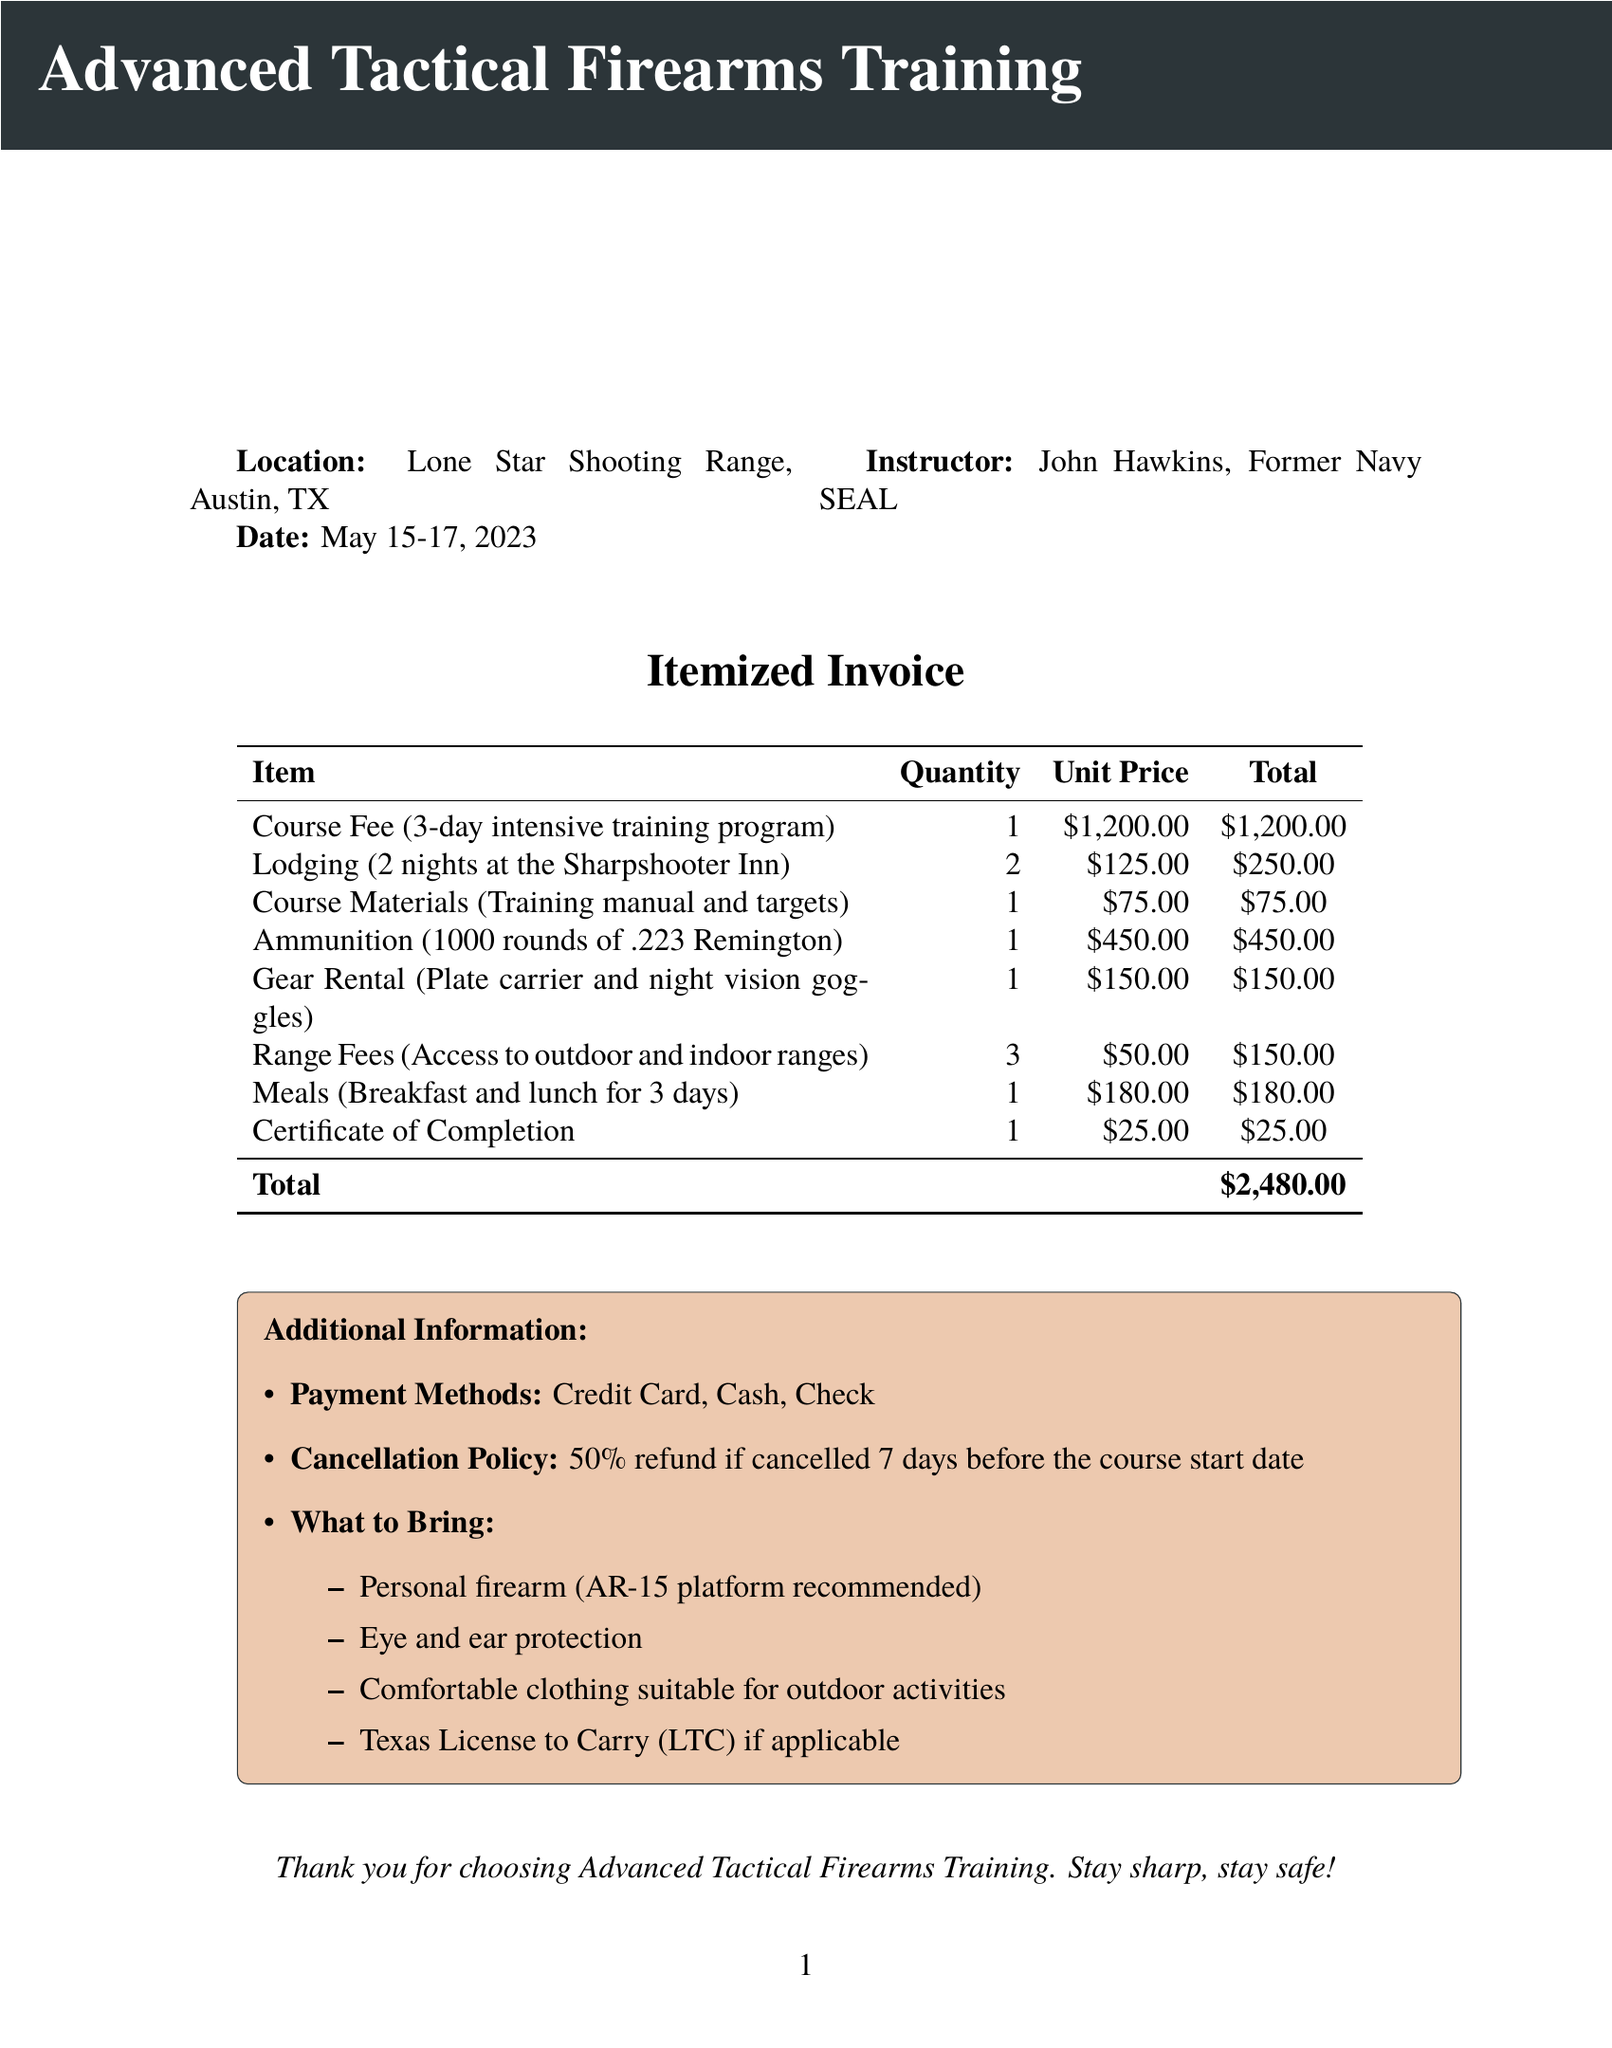what is the course name? The course name is stated at the beginning of the document, which is "Advanced Tactical Firearms Training."
Answer: Advanced Tactical Firearms Training who is the instructor? The document lists the instructor's name as "John Hawkins, Former Navy SEAL."
Answer: John Hawkins, Former Navy SEAL how much is the Course Fee? The Course Fee item is listed in the table with a unit price of $1200.00.
Answer: $1200.00 what is the total cost of lodging? Lodging costs are outlined with a unit price of $125.00 for 2 nights, making the total lodging cost $250.00.
Answer: $250.00 how many days is the training program? The document specifies that the training program lasts for 3 days.
Answer: 3 days what is the cancellation policy? The additional information section details the cancellation policy stating, "50% refund if cancelled 7 days before the course start date."
Answer: 50% refund if cancelled 7 days before the course start date what items should be brought to the course? The "What to Bring" section lists items including a personal firearm, eye and ear protection, comfortable clothing, and Texas License to Carry if applicable.
Answer: Personal firearm, eye and ear protection, comfortable clothing, Texas License to Carry if applicable what is the total amount due for the invoice? The document summarizes the total amount due as $2480.00 in the itemized table.
Answer: $2480.00 